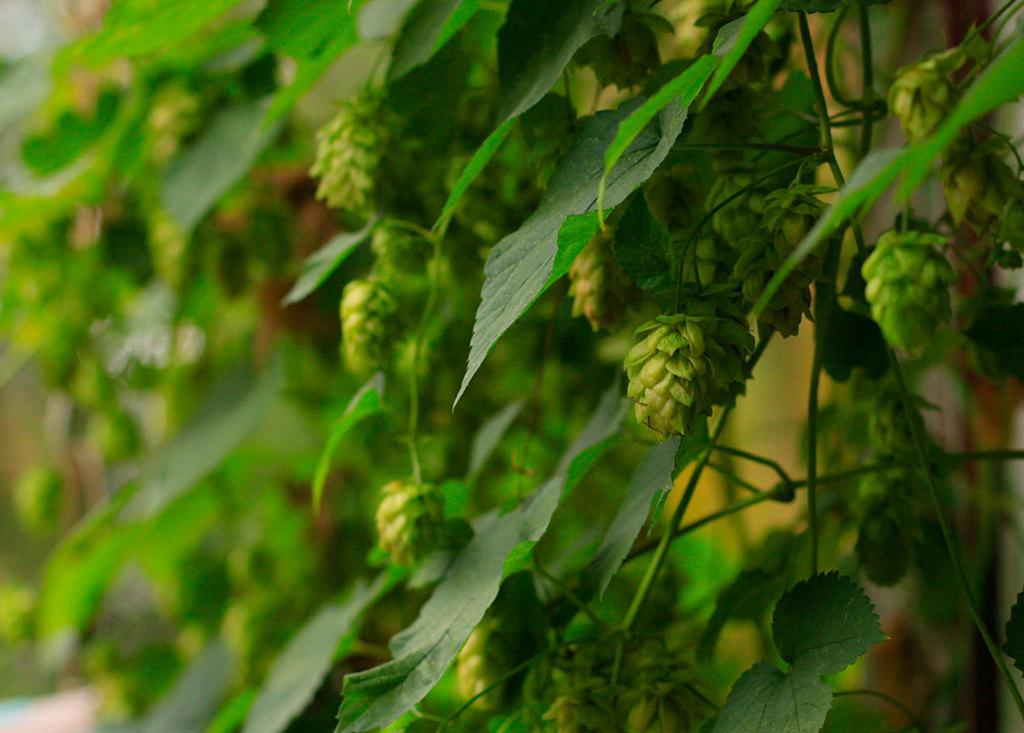What type of living organisms are present in the image? The image contains plants. What color are the leaves of the plants in the image? The plants have green leaves. What can be seen in the background of the image? There is a wall in the background of the image. Where is the drain located in the image? There is no drain present in the image. What type of seed can be seen growing on the plants in the image? There is no seed visible on the plants in the image. 